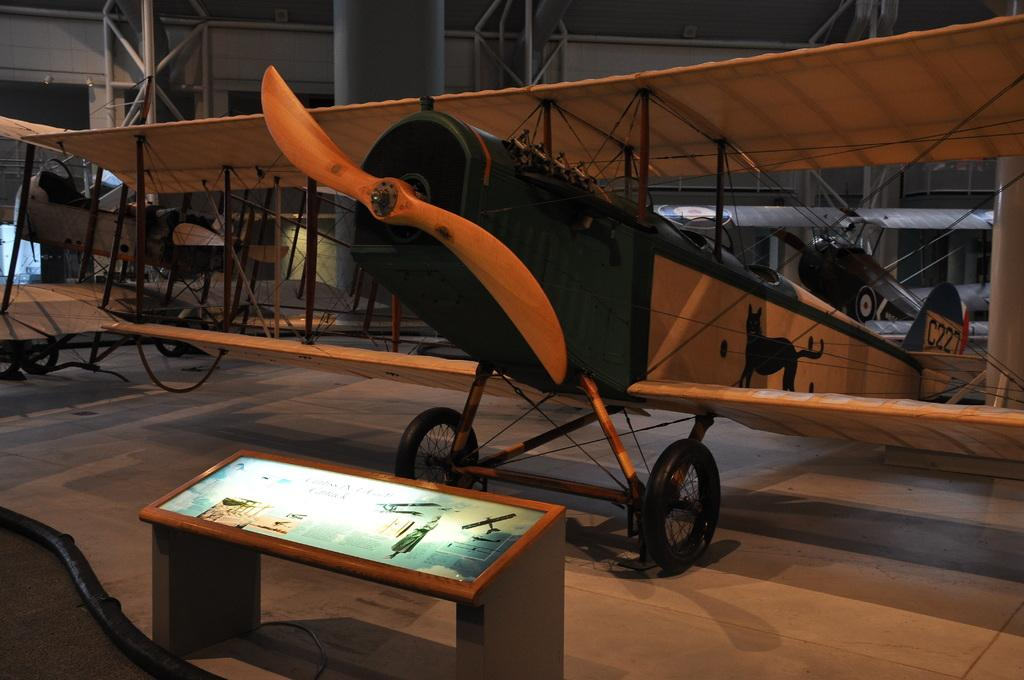What is the main subject of the picture? The main subject of the picture is an airplane. What is located in front of the airplane in the image? There is a model frame in front of the airplane. What type of clam can be seen in the model frame in the image? There is no clam present in the image, as the model frame is in front of the airplane and not related to marine life. 